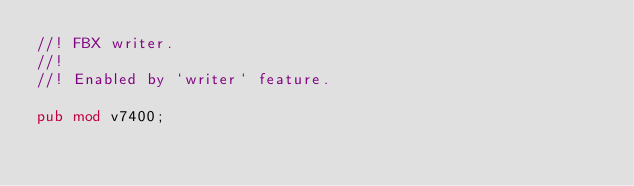Convert code to text. <code><loc_0><loc_0><loc_500><loc_500><_Rust_>//! FBX writer.
//!
//! Enabled by `writer` feature.

pub mod v7400;
</code> 